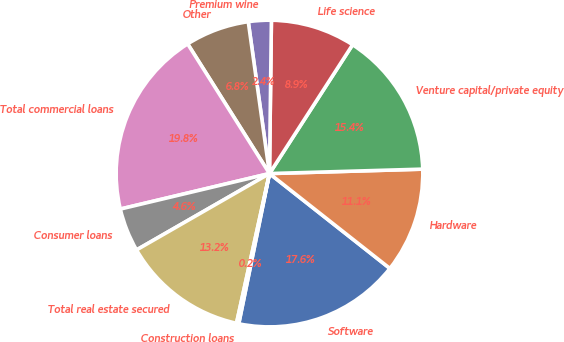Convert chart. <chart><loc_0><loc_0><loc_500><loc_500><pie_chart><fcel>Software<fcel>Hardware<fcel>Venture capital/private equity<fcel>Life science<fcel>Premium wine<fcel>Other<fcel>Total commercial loans<fcel>Consumer loans<fcel>Total real estate secured<fcel>Construction loans<nl><fcel>17.59%<fcel>11.08%<fcel>15.42%<fcel>8.92%<fcel>2.41%<fcel>6.75%<fcel>19.76%<fcel>4.58%<fcel>13.25%<fcel>0.24%<nl></chart> 